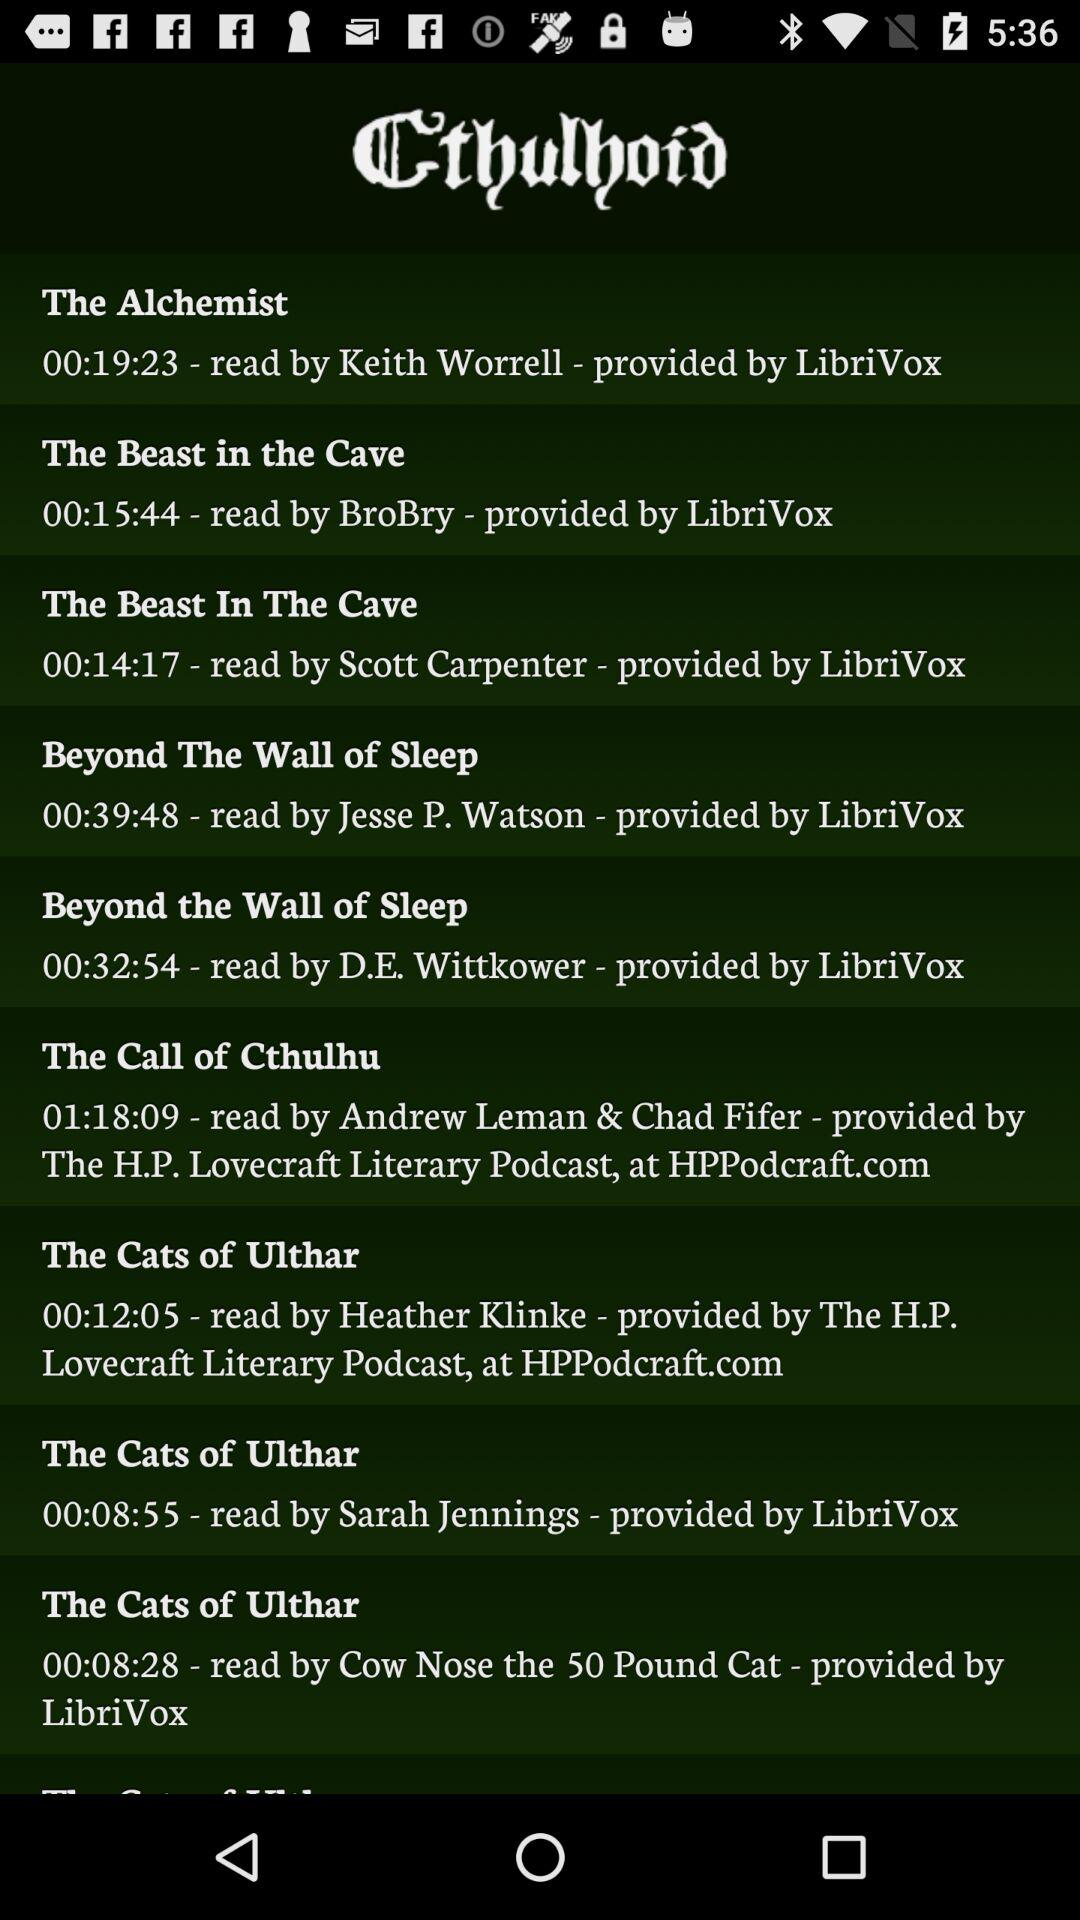What is the time duration of "The Alchemist"? The time duration of "The Alchemist" is 19 minutes 23 seconds. 